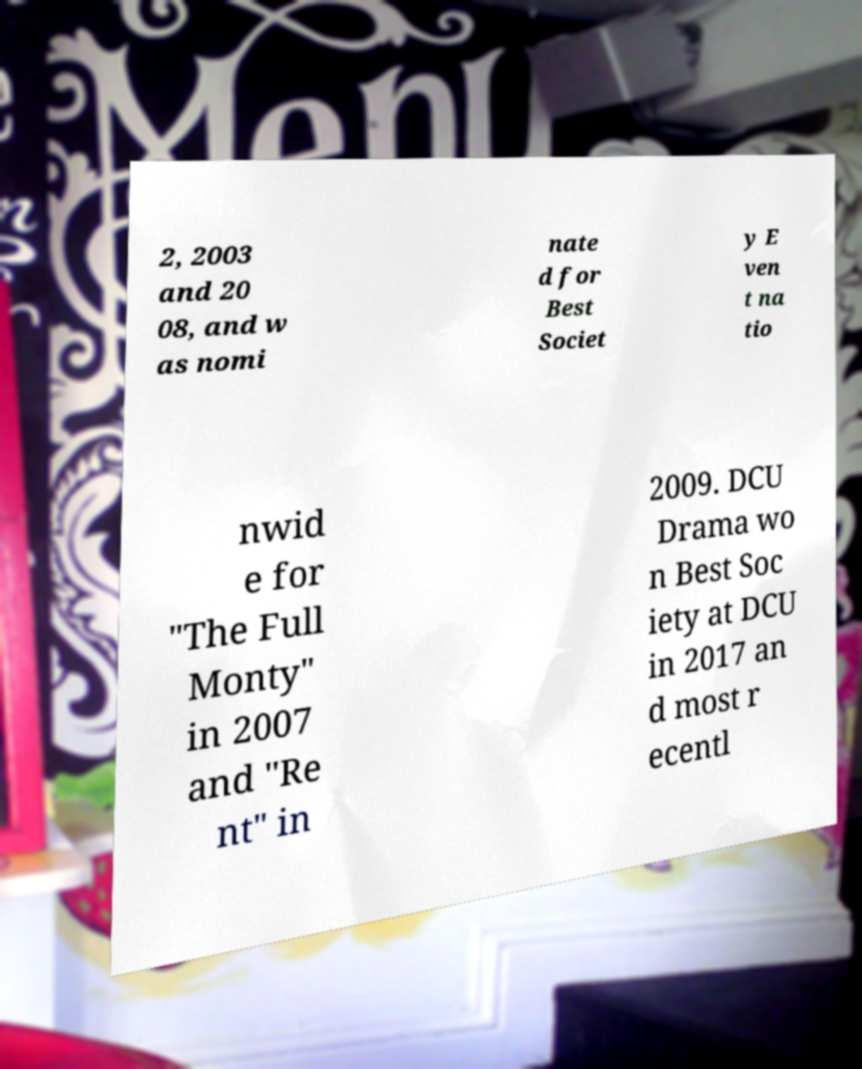Please identify and transcribe the text found in this image. 2, 2003 and 20 08, and w as nomi nate d for Best Societ y E ven t na tio nwid e for "The Full Monty" in 2007 and "Re nt" in 2009. DCU Drama wo n Best Soc iety at DCU in 2017 an d most r ecentl 